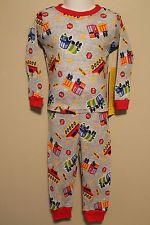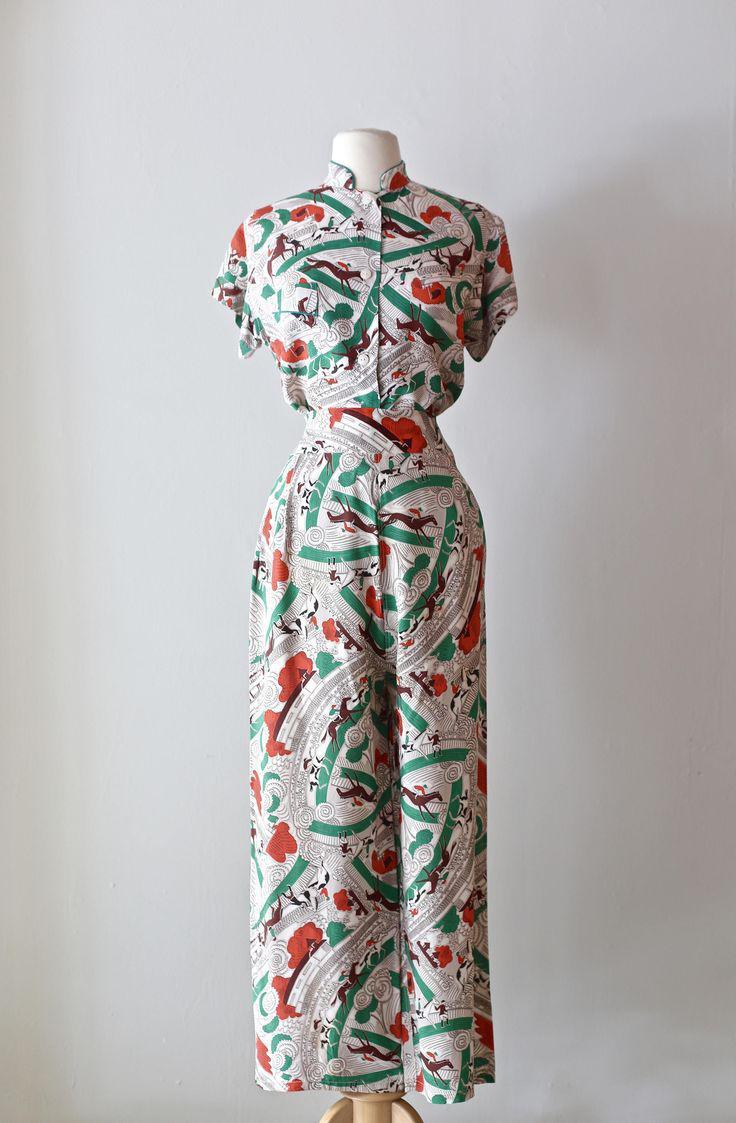The first image is the image on the left, the second image is the image on the right. Assess this claim about the two images: "A pajama set with an overall print design has wide cuffs on its long pants and long sleeved shirt, and a rounded collar on the shirt.". Correct or not? Answer yes or no. Yes. The first image is the image on the left, the second image is the image on the right. For the images displayed, is the sentence "Each image contains one outfit consisting of printed pajama pants and a coordinating top featuring the same printed pattern." factually correct? Answer yes or no. No. 